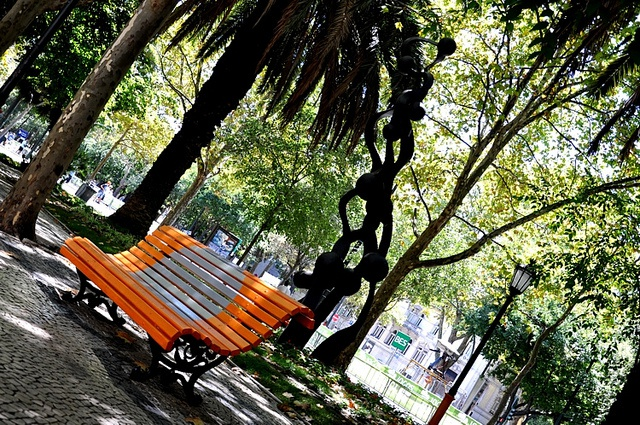Describe the objects in this image and their specific colors. I can see bench in black, red, darkgray, and maroon tones, people in black, white, darkgray, and gray tones, and people in black, white, darkgray, and gray tones in this image. 